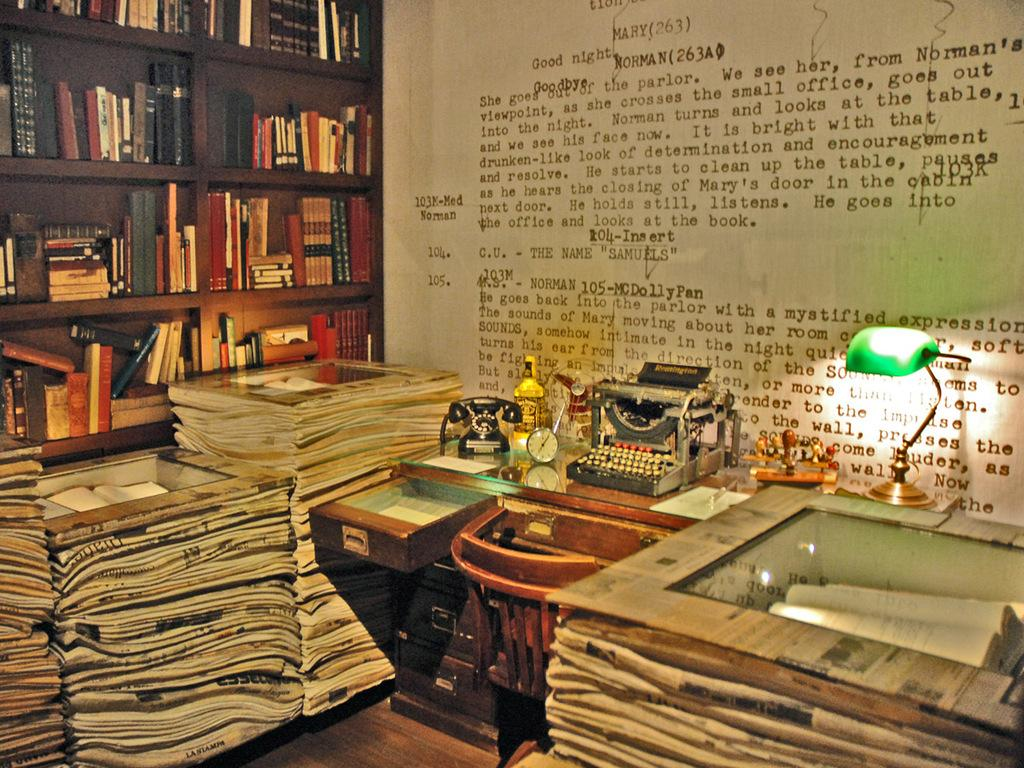Provide a one-sentence caption for the provided image. an office packed with maggazine books and writing on the wall with the words good night at the type. 